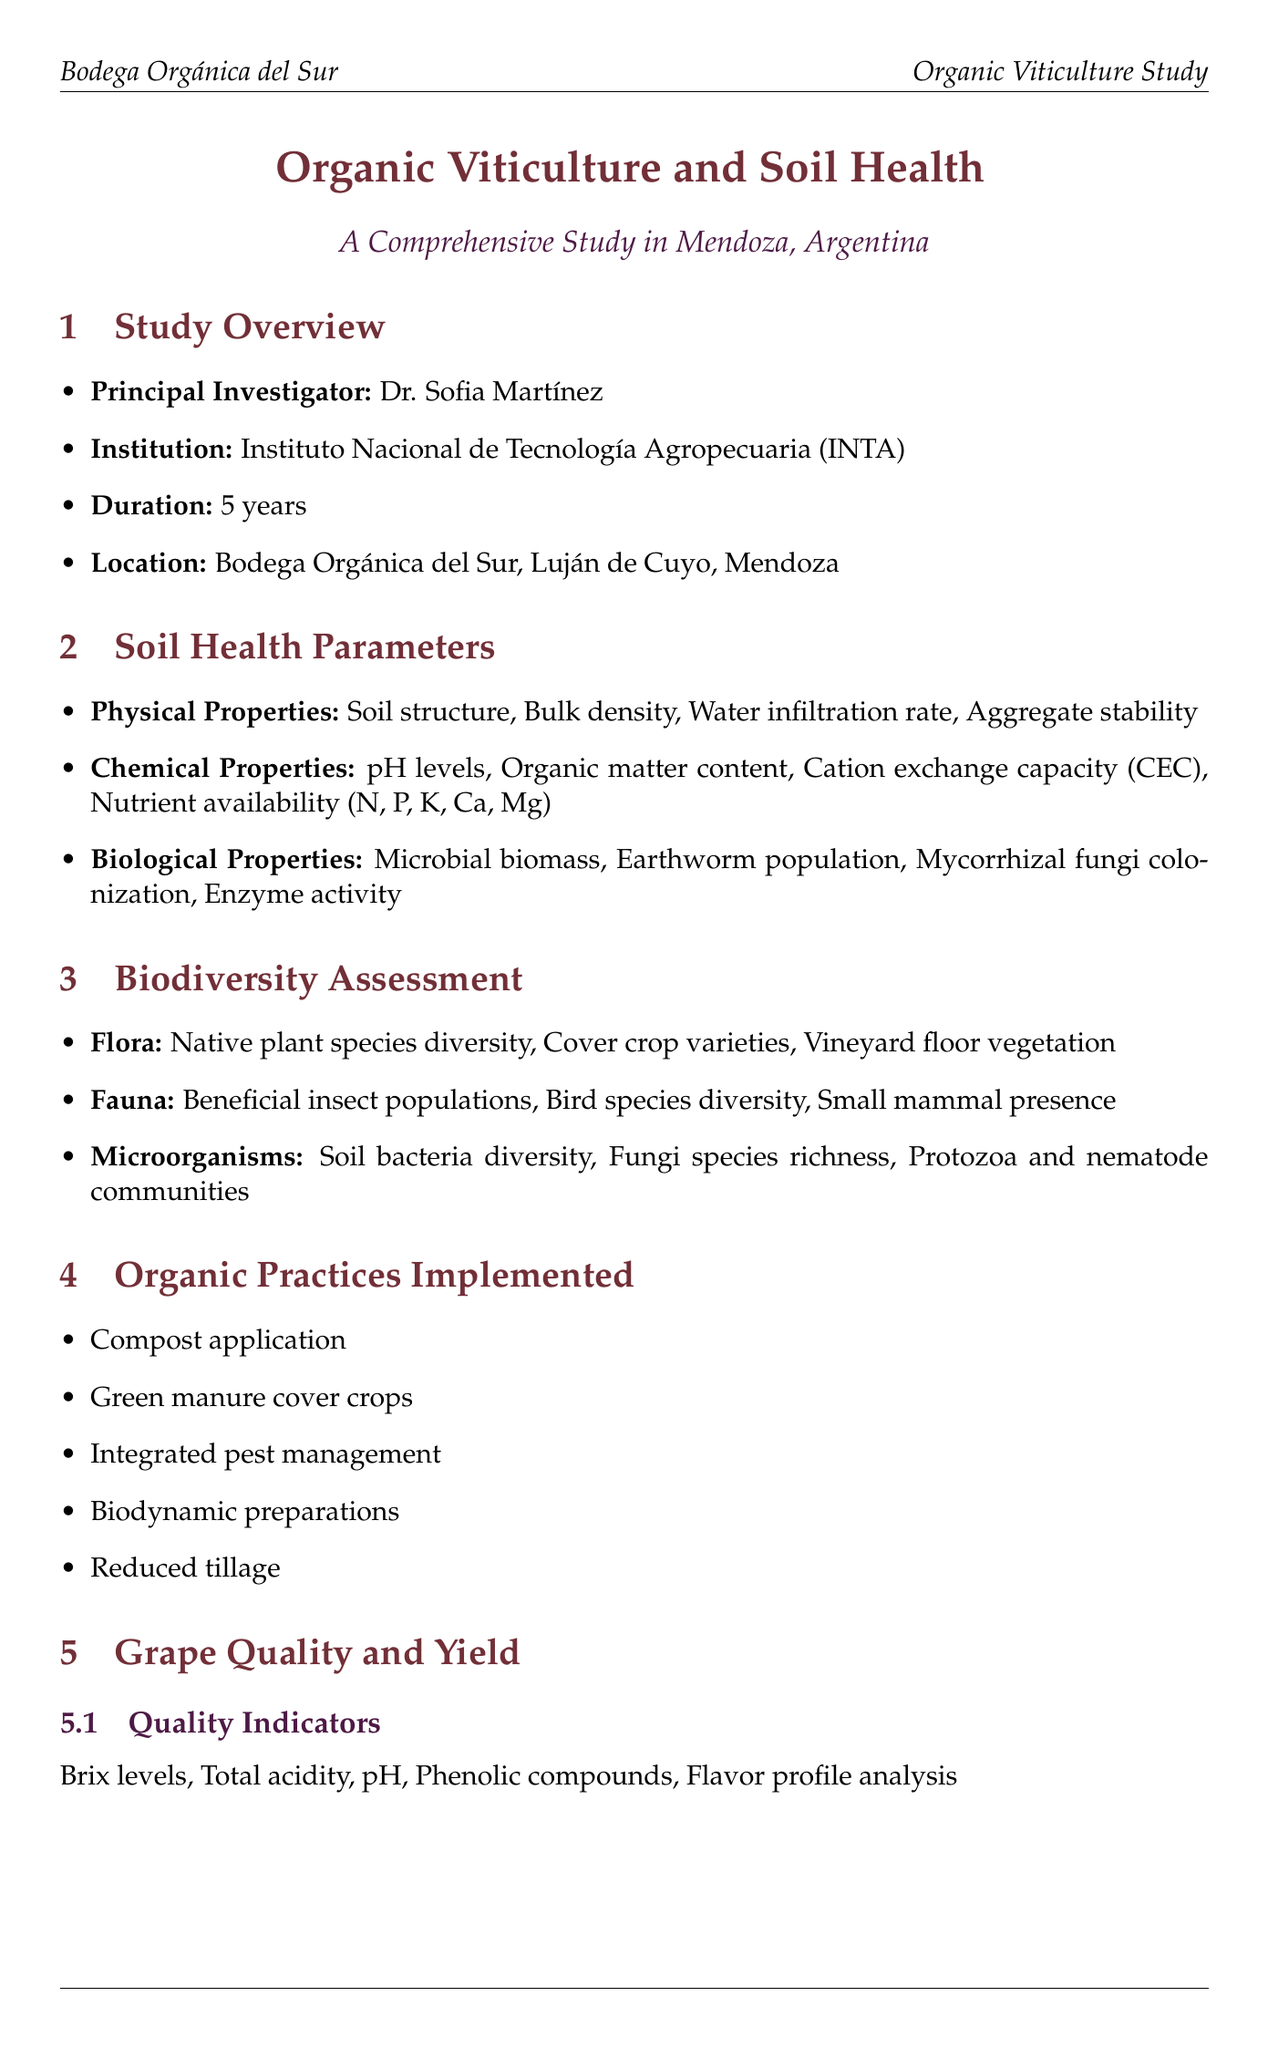What is the title of the study? The title of the study is provided as the main header in the document.
Answer: Organic Viticulture and Soil Health: A Comprehensive Study in Mendoza, Argentina Who is the principal investigator? The name of the principal investigator is mentioned in the study overview section.
Answer: Dr. Sofia Martínez What is the yield of organic grapes? The yield data for organic grapes is compared to that of conventional grapes in the yield comparison table.
Answer: 7.5 tons/hectare What percentage increase in soil organic matter content was observed? The key findings section lists the percentage increase in soil organic matter content as one of the main outcomes.
Answer: 25% What practices were implemented in the study? The organic practices implemented are listed in a dedicated section of the document.
Answer: Compost application, Green manure cover crops, Integrated pest management, Biodynamic preparations, Reduced tillage Which institution collaborated with the study? The list of collaborating institutions is provided in the collaborations and funding section of the document.
Answer: Universidad Nacional de Cuyo What is the average market price premium for organic grapes? The economic analysis section provides details on the market price for organic grapes compared to conventional.
Answer: 30% premium What type of practices were functioning to improve biodiversity? The document specifically highlights a category of practices implemented to bolster biodiversity in the vineyard.
Answer: Integrated pest management What was the duration of the study? The duration of the study is mentioned in the study overview section.
Answer: 5 years 